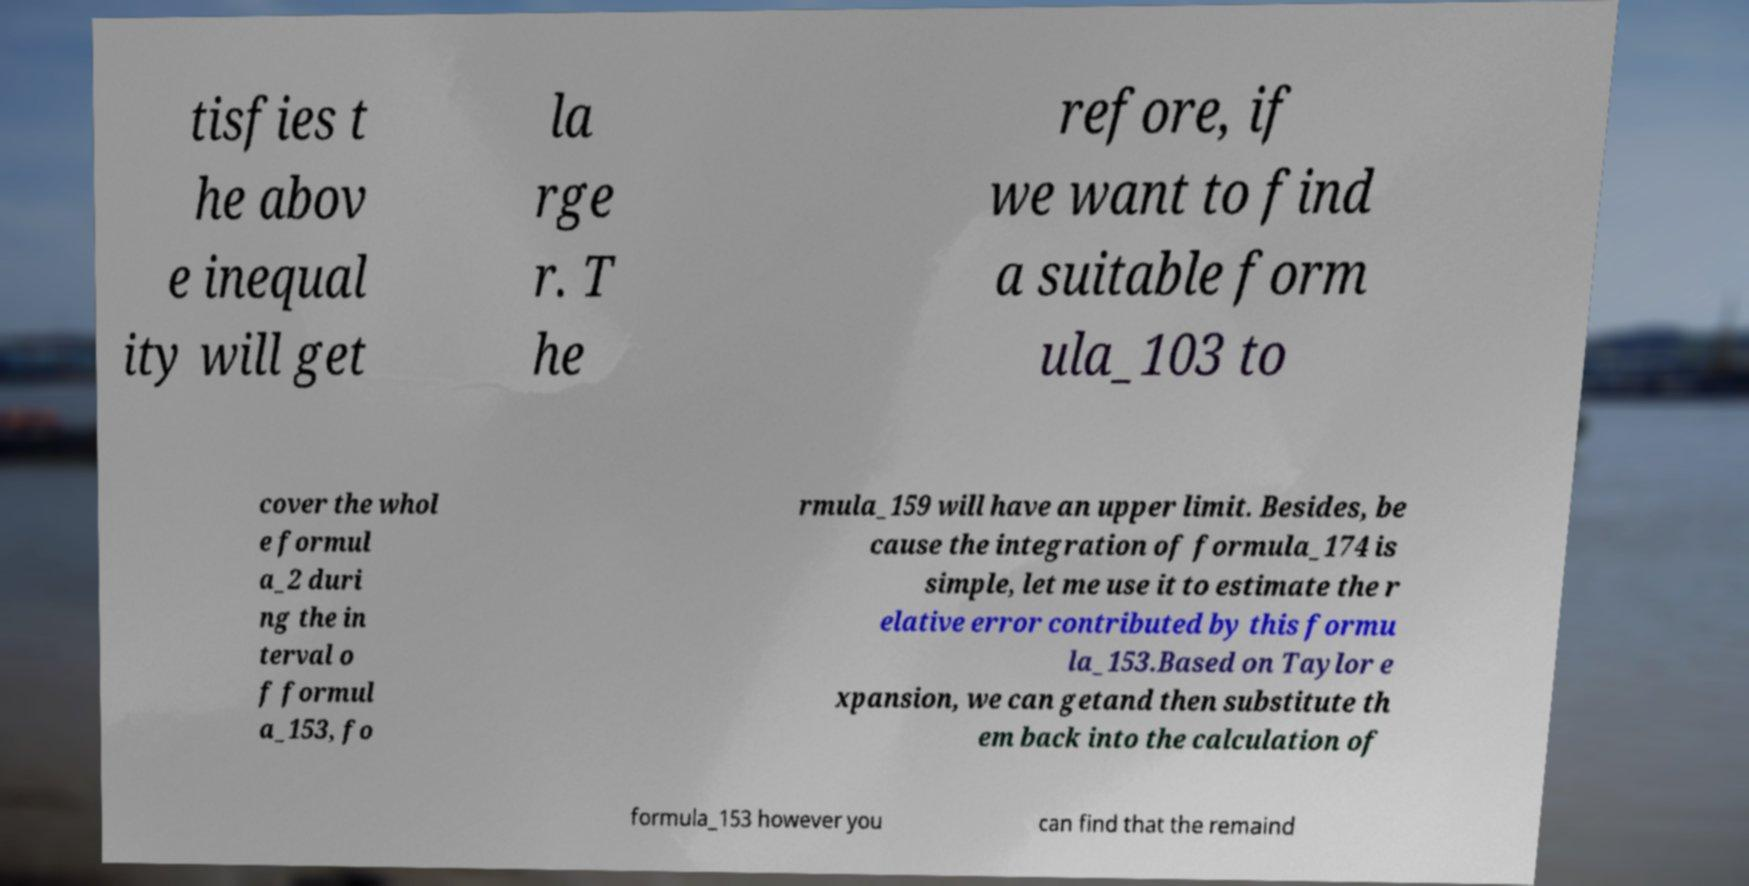Could you extract and type out the text from this image? tisfies t he abov e inequal ity will get la rge r. T he refore, if we want to find a suitable form ula_103 to cover the whol e formul a_2 duri ng the in terval o f formul a_153, fo rmula_159 will have an upper limit. Besides, be cause the integration of formula_174 is simple, let me use it to estimate the r elative error contributed by this formu la_153.Based on Taylor e xpansion, we can getand then substitute th em back into the calculation of formula_153 however you can find that the remaind 